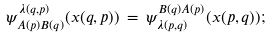Convert formula to latex. <formula><loc_0><loc_0><loc_500><loc_500>\psi ^ { \lambda ( q , p ) } _ { A ( p ) B ( q ) } ( x ( q , p ) ) \, = \, \psi _ { \lambda ( p , q ) } ^ { B ( q ) A ( p ) } ( x ( p , q ) ) ;</formula> 